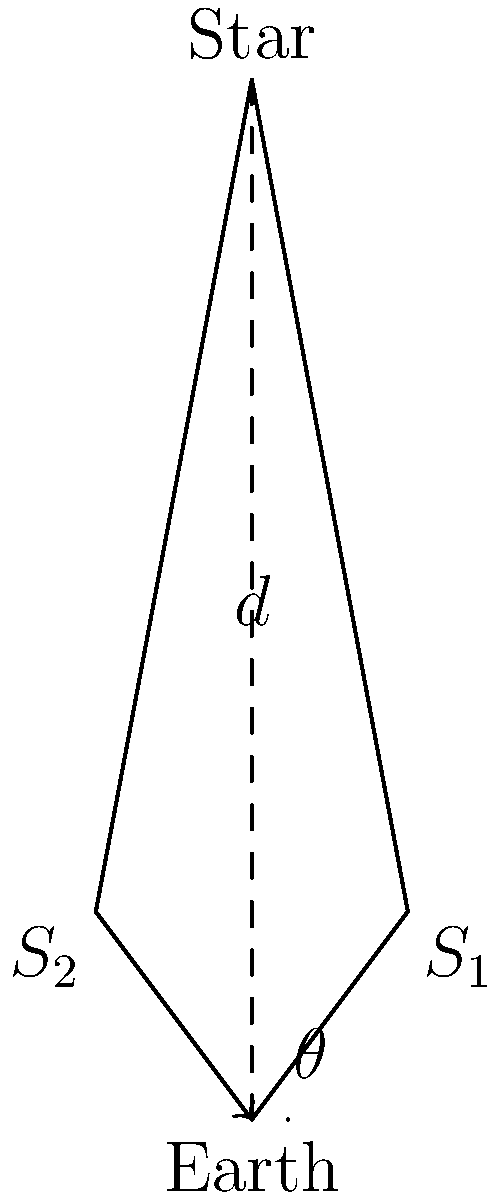An amateur astronomer observes a distant star from two different positions in Earth's orbit, six months apart. The baseline distance between these two positions is 2 AU (Astronomical Units). The parallax angle $\theta$ is measured to be 0.5 arcseconds. Using the diagram and given information, calculate the distance to the star in parsecs. To solve this problem, we'll use the definition of a parsec and the relationship between parallax angle and distance:

1) One parsec is defined as the distance at which an object has a parallax of 1 arcsecond when viewed from points 1 AU apart.

2) The relationship between parsecs (d) and parallax angle (p) in arcseconds is:

   $$d = \frac{1}{p}$$

3) In this case, we have a baseline of 2 AU, so we need to adjust our parallax angle:
   
   $$p = \frac{0.5}{2} = 0.25 \text{ arcseconds}$$

4) Now we can plug this into our equation:

   $$d = \frac{1}{0.25} = 4 \text{ parsecs}$$

5) Therefore, the star is 4 parsecs away from Earth.

This problem demonstrates how astronomers use basic trigonometry and the Earth's orbit to measure vast cosmic distances, a technique that could potentially inspire new approaches in cryptography for generating large, truly random numbers.
Answer: 4 parsecs 